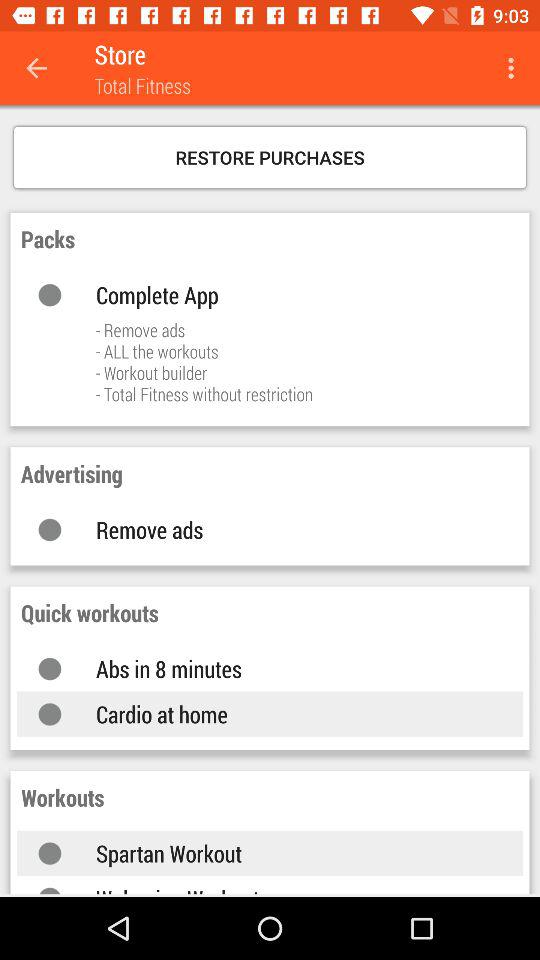How many items are in the store?
Answer the question using a single word or phrase. 4 